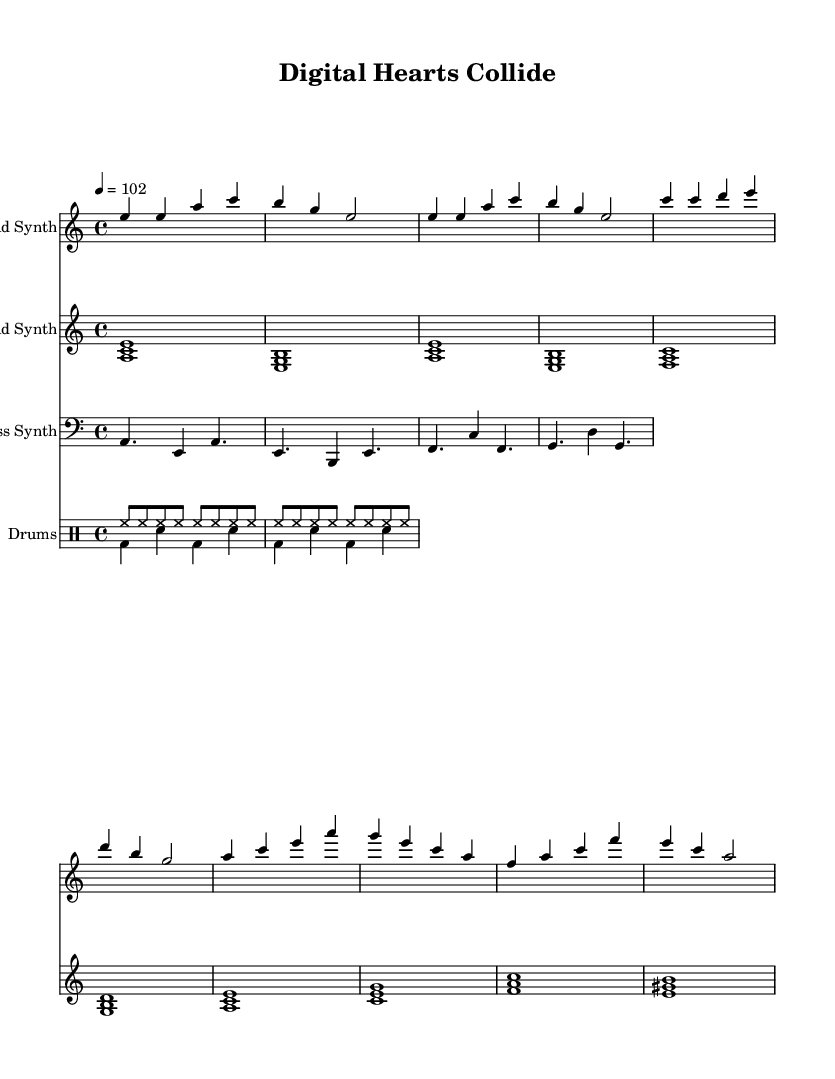What is the key signature of this music? The key signature is A minor, which has no sharps or flats. Therefore, looking at the sheet music's global section shows the key information.
Answer: A minor What is the time signature of this music? The time signature is 4/4, indicated at the beginning of the global section in the score. This means that there are four beats in each measure, and the quarter note gets one beat.
Answer: 4/4 What is the tempo marking for this piece? The tempo marking is 102, as specified in the global section of the score indicating the beats per minute. This means the piece should be played at a speed of 102 beats per minute.
Answer: 102 What notes are played in the chorus section? The chorus section consists of the notes: A, C, E, A; G, E, C, A; F, A, C, F; E, C, A. When analyzing the lead synth part, these notes can be identified in the corresponding measures.
Answer: A, C, E, A; G, E, C, A; F, A, C, F; E, C, A How many voices are present in the score? There are four voices present in the score: one for the lead synth, one for the pad synth, one for the bass synth, and two for the drums (each with their parts). By examining the score sections, the total amount of distinct voices can be counted accurately.
Answer: Four What instruments are indicated in the score? The instruments indicated in the score are Lead Synth, Pad Synth, Bass Synth, and Drums. This can be identified by looking at the staff names at the start of each corresponding section.
Answer: Lead Synth, Pad Synth, Bass Synth, Drums 